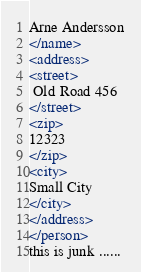Convert code to text. <code><loc_0><loc_0><loc_500><loc_500><_XML_>Arne Andersson
</name>
<address>
<street>
 Old Road 456
</street>
<zip>
12323
</zip>
<city>
Small City
</city>
</address>
</person>
this is junk ......
</code> 